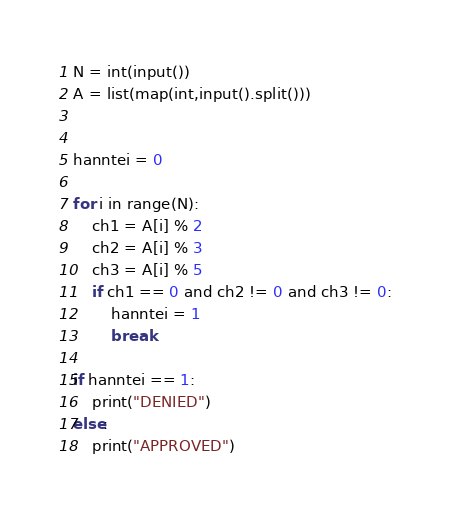<code> <loc_0><loc_0><loc_500><loc_500><_Python_>N = int(input())
A = list(map(int,input().split()))


hanntei = 0 

for i in range(N):
    ch1 = A[i] % 2
    ch2 = A[i] % 3
    ch3 = A[i] % 5
    if ch1 == 0 and ch2 != 0 and ch3 != 0:
        hanntei = 1
        break

if hanntei == 1:
    print("DENIED")
else:
    print("APPROVED")</code> 